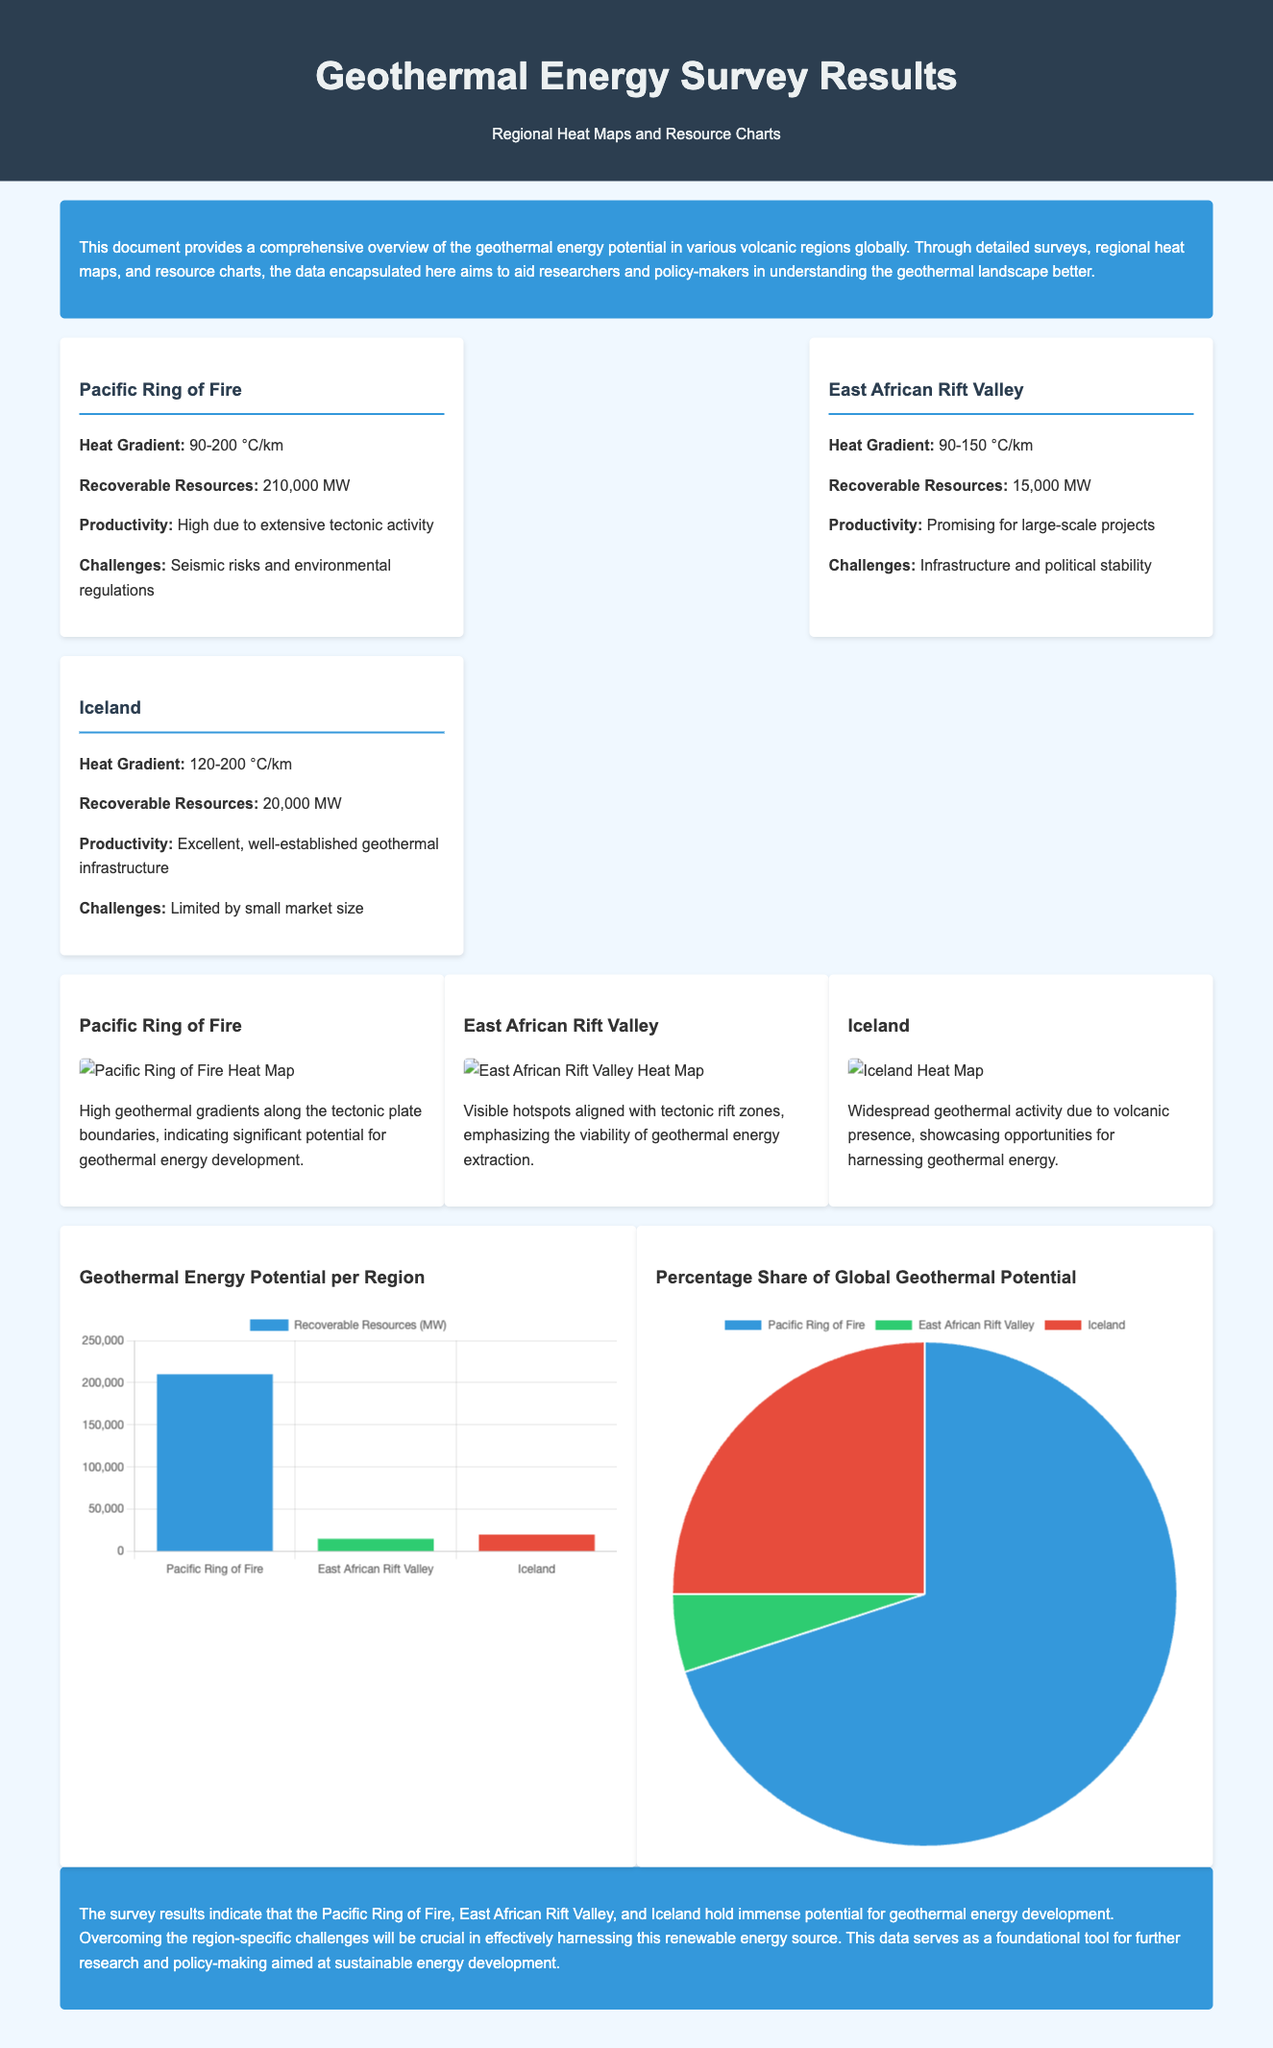What is the heat gradient for the Pacific Ring of Fire? The heat gradient for the Pacific Ring of Fire is specified in the document as 90-200 °C/km.
Answer: 90-200 °C/km What is the recoverable resource capacity of the East African Rift Valley? The document states that the recoverable resource capacity for the East African Rift Valley is 15,000 MW.
Answer: 15,000 MW What color represents the Pacific Ring of Fire in the pie chart? The document indicates that the color for the Pacific Ring of Fire in the pie chart is blue, corresponding to the value labels provided.
Answer: Blue Which region has the highest recoverable resources according to the survey results? The survey results indicate that the Pacific Ring of Fire has the highest recoverable resources, at 210,000 MW.
Answer: Pacific Ring of Fire What challenge is associated with geothermal development in Iceland? The document outlines that a challenge for geothermal development in Iceland is limited by the small market size.
Answer: Small market size What percentage share does the East African Rift Valley hold in global geothermal potential? According to the pie chart in the document, the East African Rift Valley holds a 5% share of global geothermal potential.
Answer: 5% What is the primary aim of this document? The document aims to provide a comprehensive overview of geothermal energy potential worldwide, assisting researchers and policy-makers.
Answer: Comprehensive overview Which volcanic region has excellent geothermal productivity? The document states that Iceland has excellent geothermal productivity due to its well-established infrastructure.
Answer: Iceland What are the visible hotspots in East African Rift Valley aligned with? The document explains that visible hotspots in the East African Rift Valley are aligned with tectonic rift zones, indicating viability for geothermal extraction.
Answer: Tectonic rift zones 